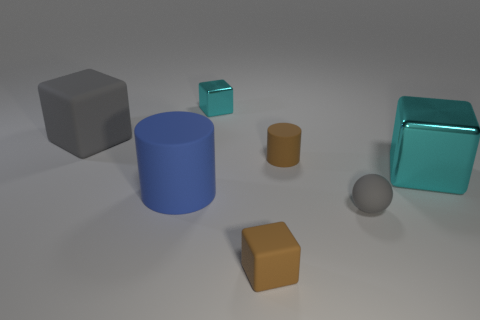What number of cubes have the same color as the tiny rubber ball?
Offer a very short reply. 1. What material is the thing that is the same color as the rubber ball?
Offer a terse response. Rubber. There is a small cyan metallic object; does it have the same shape as the small brown object in front of the small gray thing?
Ensure brevity in your answer.  Yes. What is the color of the matte cube that is in front of the large gray rubber cube?
Your response must be concise. Brown. There is a brown thing that is behind the tiny cube that is in front of the tiny cyan thing; what is its size?
Give a very brief answer. Small. Do the large gray matte object that is on the left side of the brown matte block and the large shiny object have the same shape?
Give a very brief answer. Yes. What is the material of the large gray object that is the same shape as the large cyan metal thing?
Provide a short and direct response. Rubber. What number of things are tiny matte objects that are behind the big blue object or brown matte objects that are behind the tiny sphere?
Your response must be concise. 1. Is the color of the tiny rubber cube the same as the tiny matte thing that is behind the big blue cylinder?
Your answer should be very brief. Yes. The large gray object that is the same material as the blue object is what shape?
Your answer should be compact. Cube. 